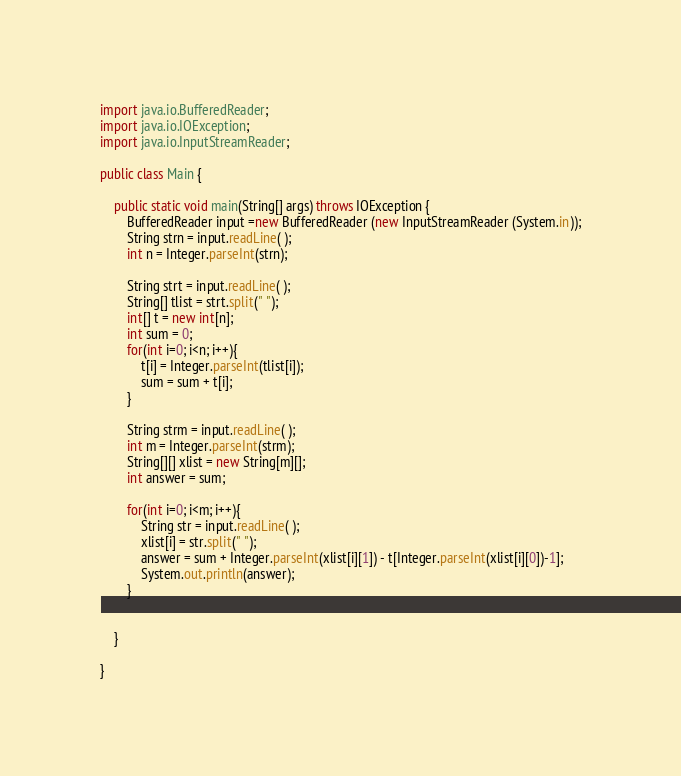Convert code to text. <code><loc_0><loc_0><loc_500><loc_500><_Java_>import java.io.BufferedReader;
import java.io.IOException;
import java.io.InputStreamReader;

public class Main {

	public static void main(String[] args) throws IOException {
		BufferedReader input =new BufferedReader (new InputStreamReader (System.in));
		String strn = input.readLine( );
		int n = Integer.parseInt(strn);

		String strt = input.readLine( );
		String[] tlist = strt.split(" ");
		int[] t = new int[n];
		int sum = 0;
		for(int i=0; i<n; i++){
			t[i] = Integer.parseInt(tlist[i]);
			sum = sum + t[i];
		}

		String strm = input.readLine( );
		int m = Integer.parseInt(strm);
		String[][] xlist = new String[m][];
		int answer = sum;

		for(int i=0; i<m; i++){
			String str = input.readLine( );
			xlist[i] = str.split(" ");
			answer = sum + Integer.parseInt(xlist[i][1]) - t[Integer.parseInt(xlist[i][0])-1];
			System.out.println(answer);
		}


	}

}
</code> 